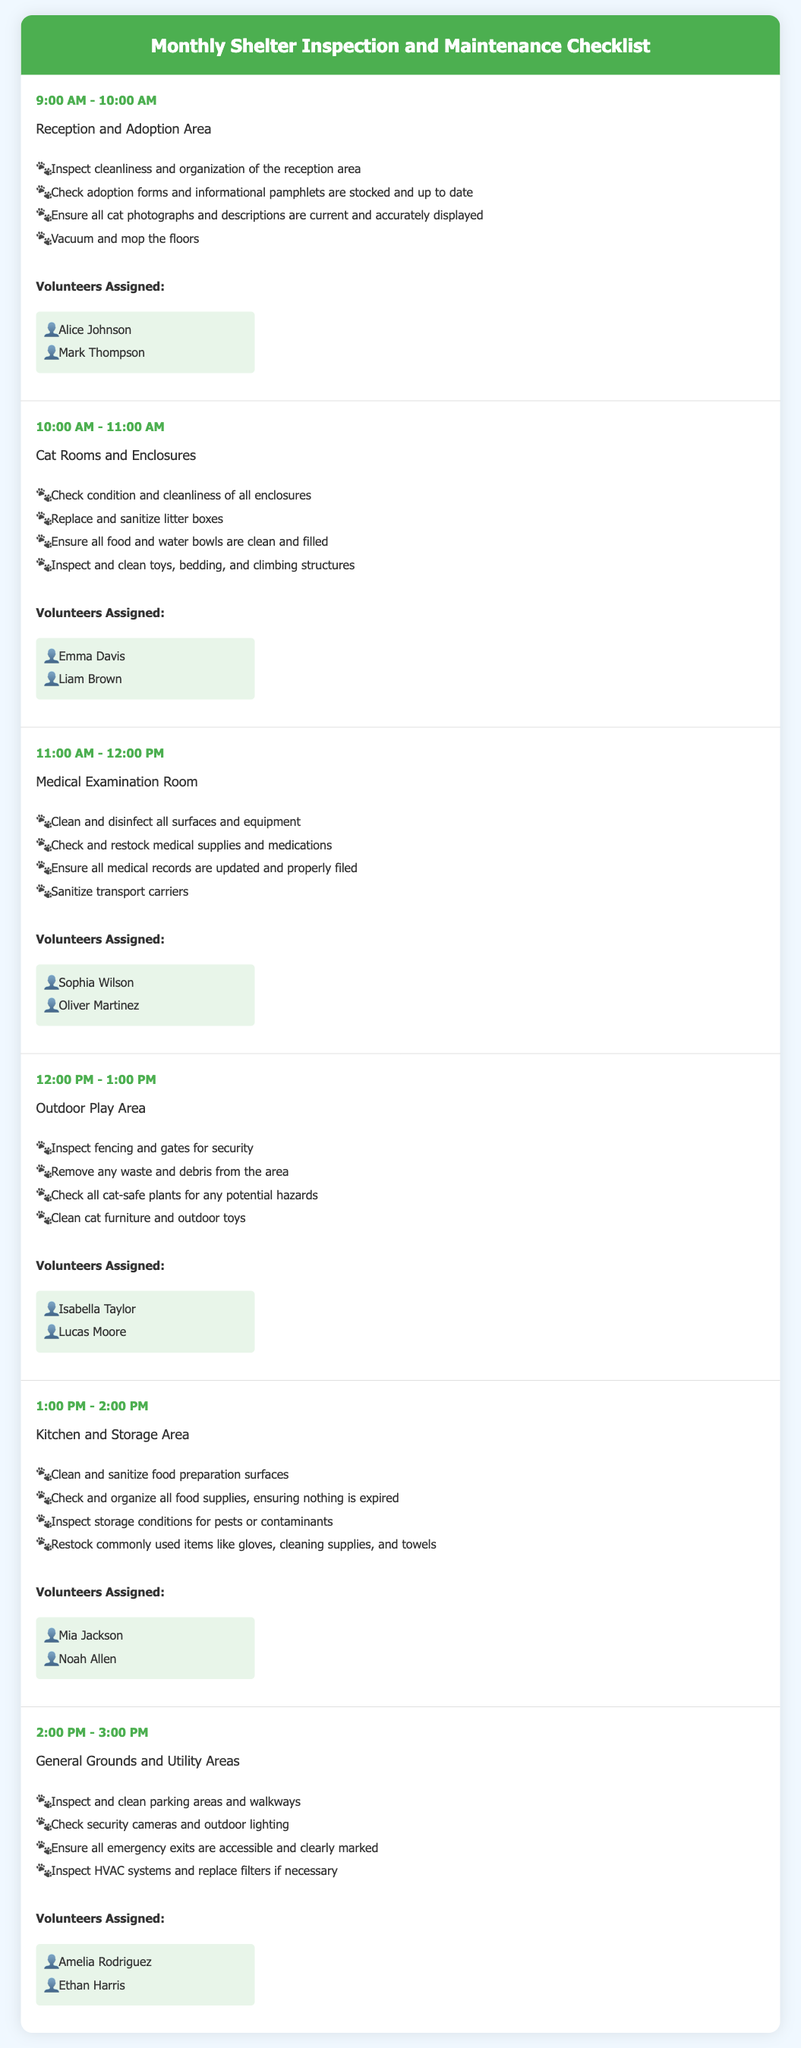What is the first area to be inspected? The first area listed in the itinerary is the Reception and Adoption Area, scheduled for inspection at 9:00 AM.
Answer: Reception and Adoption Area Who is assigned to inspect the Medical Examination Room? Volunteers assigned to inspect the Medical Examination Room are listed in that section, which includes Sophia Wilson and Oliver Martinez.
Answer: Sophia Wilson, Oliver Martinez What time is the inspection of the Outdoor Play Area scheduled? The time for inspecting the Outdoor Play Area is specifically mentioned in the itinerary, which states it is scheduled for 12:00 PM - 1:00 PM.
Answer: 12:00 PM - 1:00 PM How long is allocated for inspecting General Grounds and Utility Areas? The time allocated for inspecting the General Grounds and Utility Areas is mentioned, indicating it takes place from 2:00 PM to 3:00 PM.
Answer: 1 hour What task involves sanitizing food preparation surfaces? The specific task involving sanitizing food preparation surfaces is mentioned in the Kitchen and Storage Area section, indicating it needs to be done.
Answer: Clean and sanitize food preparation surfaces Which volunteers are assigned to the Kitchen and Storage Area? The assigned volunteers are listed explicitly in the appropriate section, which includes Mia Jackson and Noah Allen.
Answer: Mia Jackson, Noah Allen What safety feature is checked in the General Grounds and Utility Areas? One of the tasks in the General Grounds and Utility Areas mentions ensuring that emergency exits are accessible and clearly marked, indicating a focus on safety.
Answer: Emergency exits How many areas are inspected from 9:00 AM to 3:00 PM? The document outlines six different areas inspected throughout the day from 9:00 AM to 3:00 PM, giving a clear count.
Answer: Six areas 